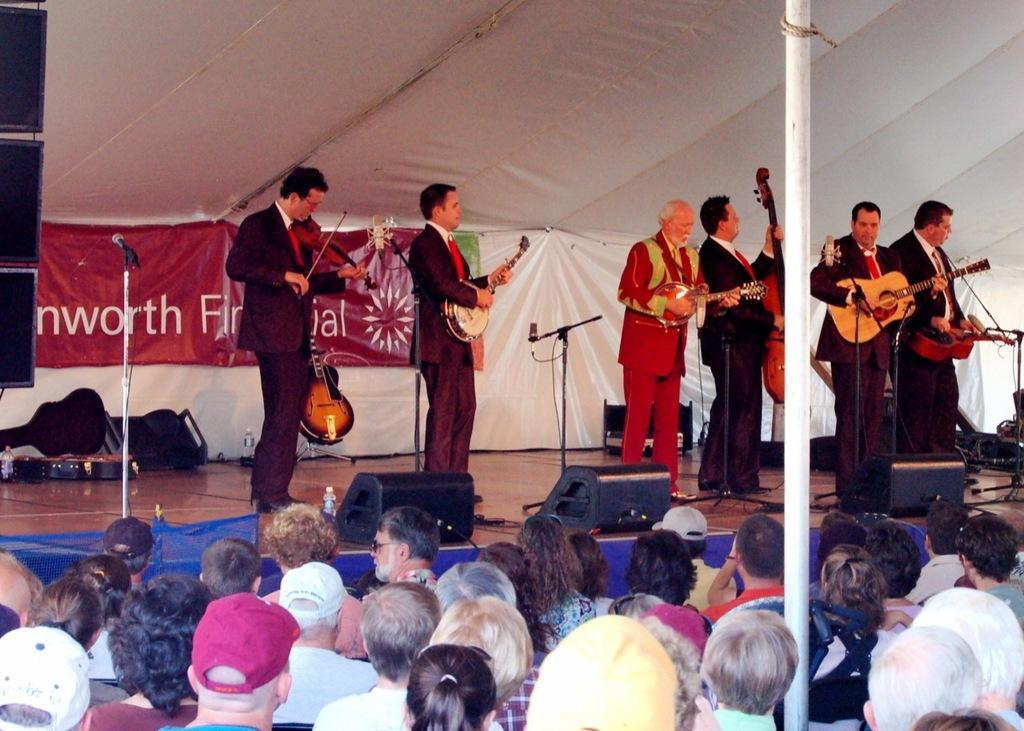Could you give a brief overview of what you see in this image? As we can see in he image there is a white color cloth, few people standing on stage and holding guitars in their hands and there are people watching them. 